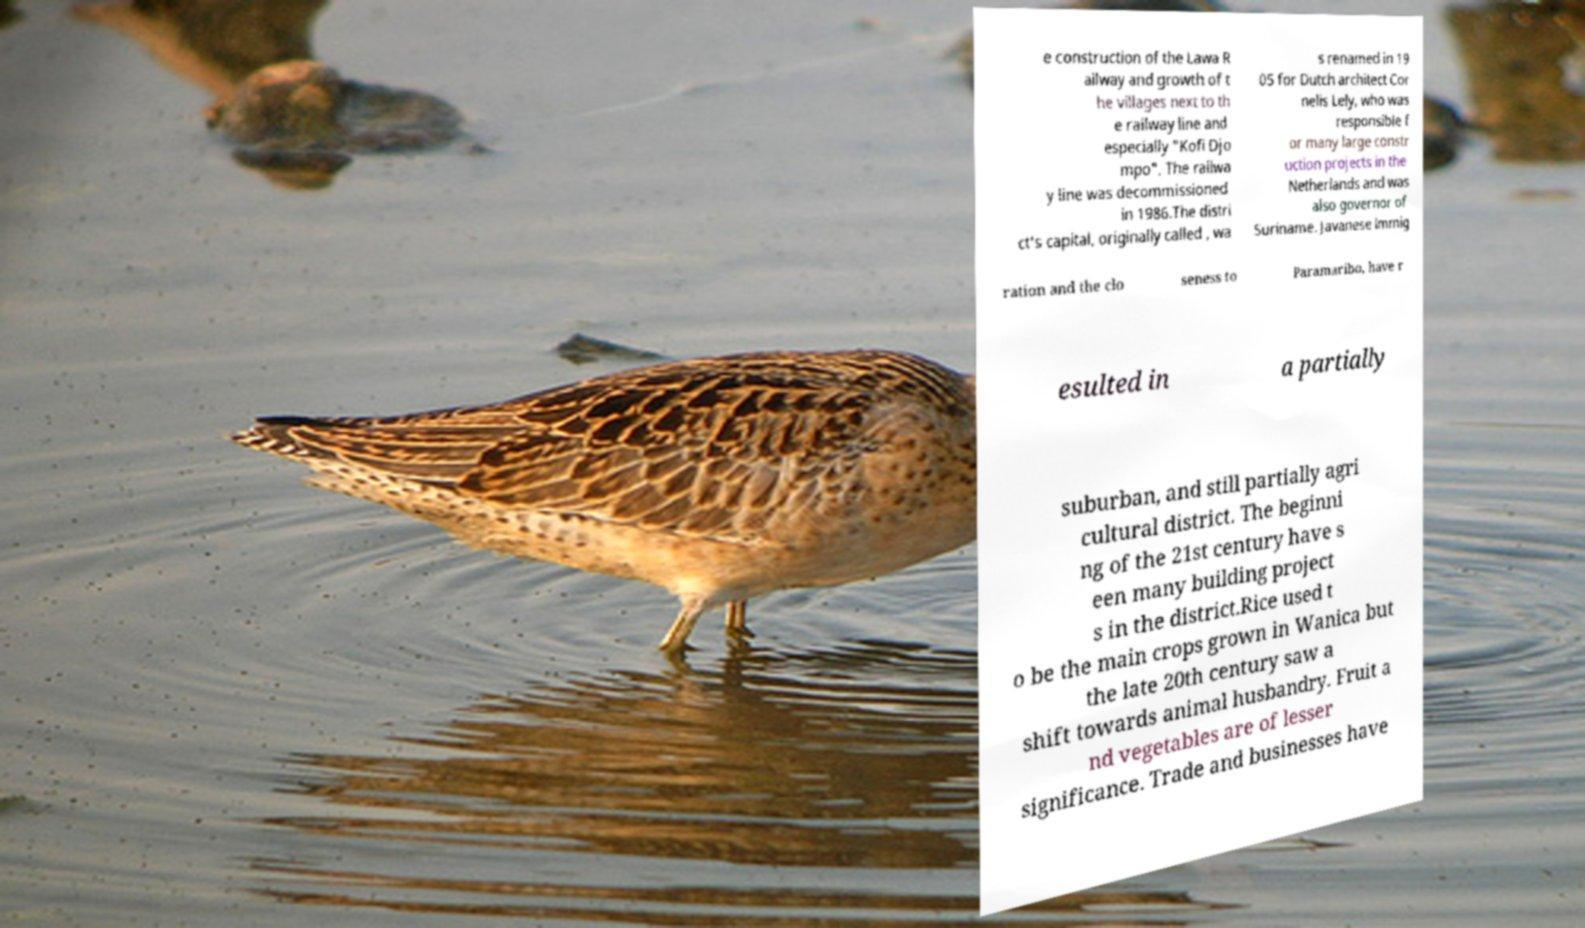Please identify and transcribe the text found in this image. e construction of the Lawa R ailway and growth of t he villages next to th e railway line and especially "Kofi Djo mpo". The railwa y line was decommissioned in 1986.The distri ct's capital, originally called , wa s renamed in 19 05 for Dutch architect Cor nelis Lely, who was responsible f or many large constr uction projects in the Netherlands and was also governor of Suriname. Javanese immig ration and the clo seness to Paramaribo, have r esulted in a partially suburban, and still partially agri cultural district. The beginni ng of the 21st century have s een many building project s in the district.Rice used t o be the main crops grown in Wanica but the late 20th century saw a shift towards animal husbandry. Fruit a nd vegetables are of lesser significance. Trade and businesses have 